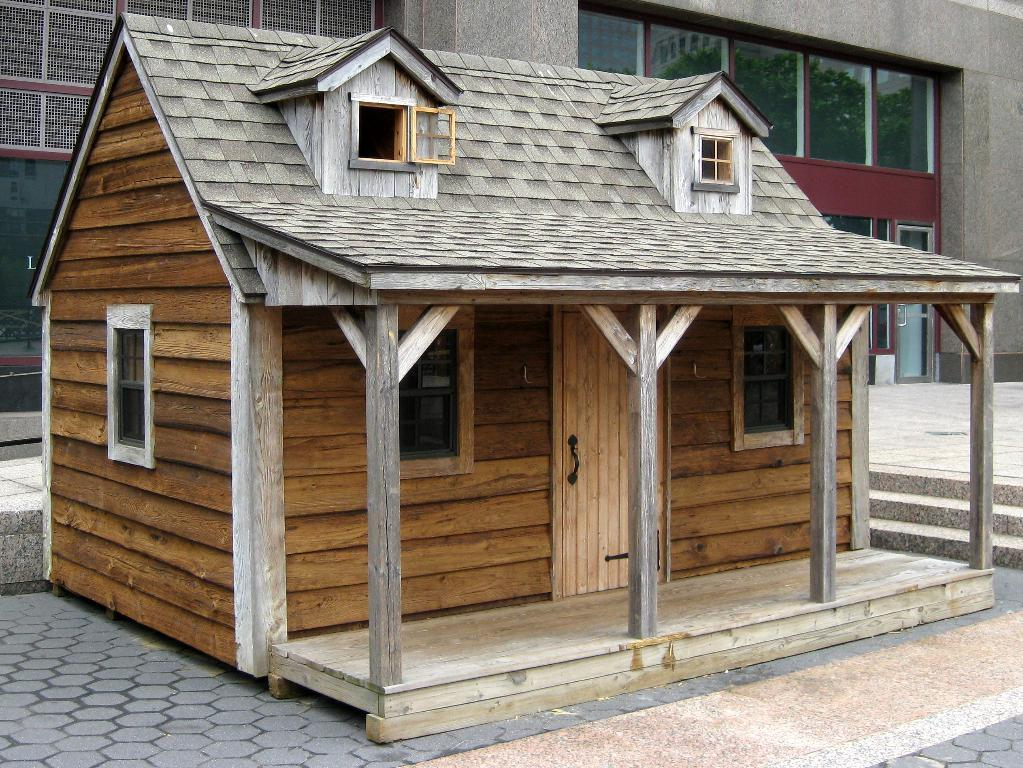What type of house is in the image? There is a wooden house in the image. What features can be seen on the wooden house? The wooden house has windows and a door. What architectural element is present in the image? There are steps in the image. What can be seen in the background of the image? There is a building with glass doors in the background of the image. What features can be seen on the building in the background? The building in the background has windows. What is the value of the answer in the image? There is no answer present in the image, so it is not possible to determine its value. 